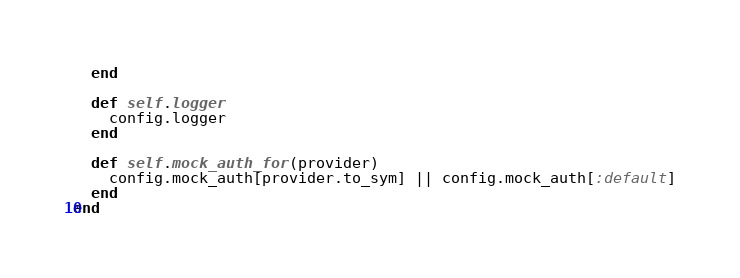Convert code to text. <code><loc_0><loc_0><loc_500><loc_500><_Ruby_>  end

  def self.logger
    config.logger
  end

  def self.mock_auth_for(provider)
    config.mock_auth[provider.to_sym] || config.mock_auth[:default]
  end
end
</code> 